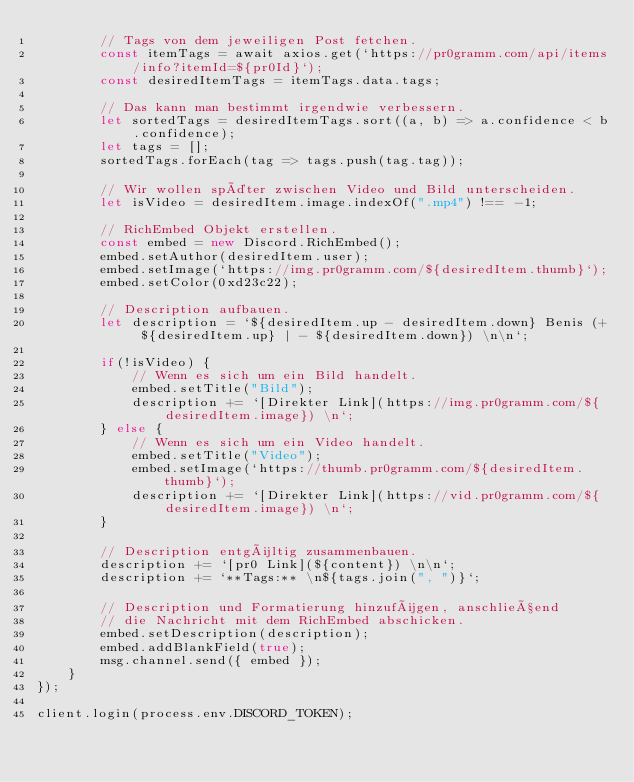Convert code to text. <code><loc_0><loc_0><loc_500><loc_500><_JavaScript_>		// Tags von dem jeweiligen Post fetchen.
		const itemTags = await axios.get(`https://pr0gramm.com/api/items/info?itemId=${pr0Id}`);
		const desiredItemTags = itemTags.data.tags;

		// Das kann man bestimmt irgendwie verbessern.
		let sortedTags = desiredItemTags.sort((a, b) => a.confidence < b.confidence);
		let tags = [];
		sortedTags.forEach(tag => tags.push(tag.tag));

		// Wir wollen später zwischen Video und Bild unterscheiden.
		let isVideo = desiredItem.image.indexOf(".mp4") !== -1;
		
		// RichEmbed Objekt erstellen.
		const embed = new Discord.RichEmbed();
		embed.setAuthor(desiredItem.user);
		embed.setImage(`https://img.pr0gramm.com/${desiredItem.thumb}`);
		embed.setColor(0xd23c22);

		// Description aufbauen.
		let description = `${desiredItem.up - desiredItem.down} Benis (+ ${desiredItem.up} | - ${desiredItem.down}) \n\n`;

		if(!isVideo) {
			// Wenn es sich um ein Bild handelt.
			embed.setTitle("Bild");
			description += `[Direkter Link](https://img.pr0gramm.com/${desiredItem.image}) \n`;
		} else {
			// Wenn es sich um ein Video handelt.
			embed.setTitle("Video");
			embed.setImage(`https://thumb.pr0gramm.com/${desiredItem.thumb}`);
			description += `[Direkter Link](https://vid.pr0gramm.com/${desiredItem.image}) \n`;
		}

		// Description entgültig zusammenbauen.
		description += `[pr0 Link](${content}) \n\n`;
		description += `**Tags:** \n${tags.join(", ")}`;

		// Description und Formatierung hinzufügen, anschließend
		// die Nachricht mit dem RichEmbed abschicken.
		embed.setDescription(description);
		embed.addBlankField(true);
		msg.channel.send({ embed });
	}
});

client.login(process.env.DISCORD_TOKEN);</code> 